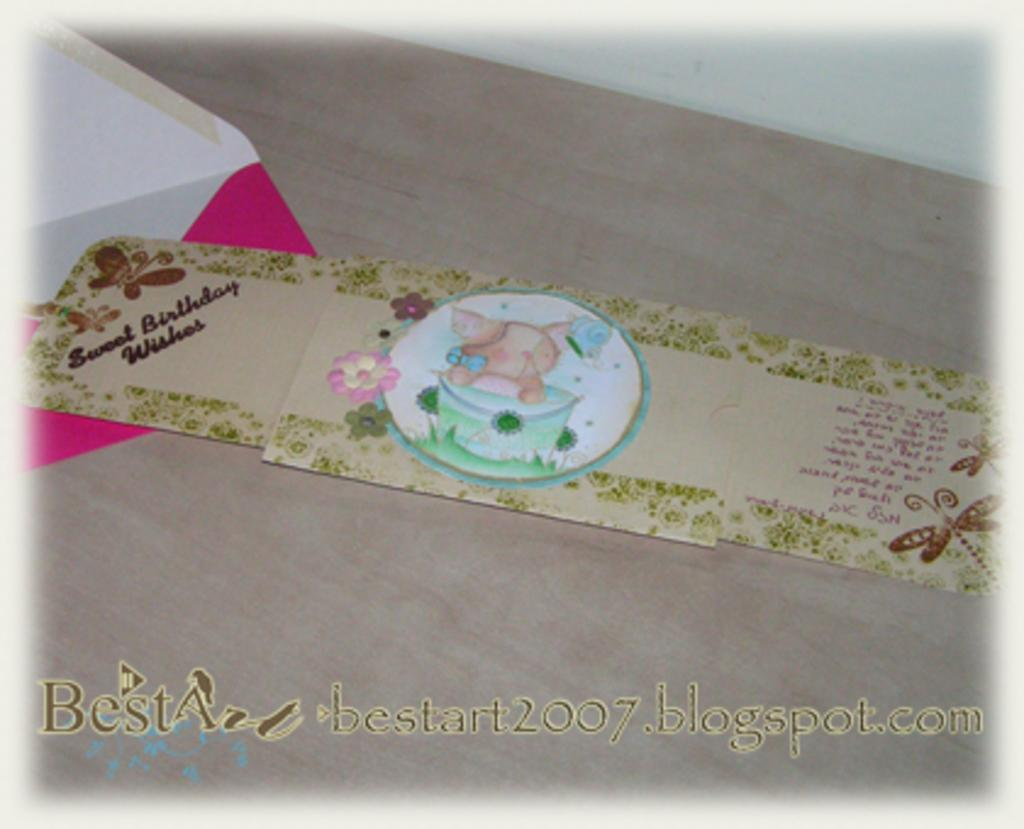<image>
Provide a brief description of the given image. a card that says BestArt on the front of it 